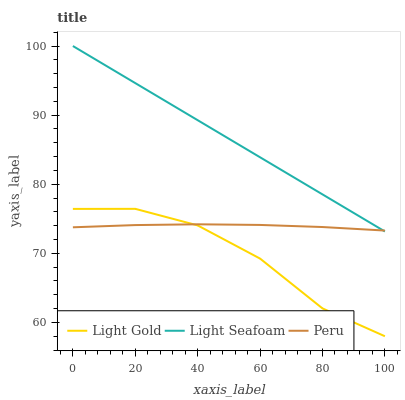Does Light Gold have the minimum area under the curve?
Answer yes or no. Yes. Does Light Seafoam have the maximum area under the curve?
Answer yes or no. Yes. Does Peru have the minimum area under the curve?
Answer yes or no. No. Does Peru have the maximum area under the curve?
Answer yes or no. No. Is Light Seafoam the smoothest?
Answer yes or no. Yes. Is Light Gold the roughest?
Answer yes or no. Yes. Is Peru the smoothest?
Answer yes or no. No. Is Peru the roughest?
Answer yes or no. No. Does Light Gold have the lowest value?
Answer yes or no. Yes. Does Peru have the lowest value?
Answer yes or no. No. Does Light Seafoam have the highest value?
Answer yes or no. Yes. Does Light Gold have the highest value?
Answer yes or no. No. Is Light Gold less than Light Seafoam?
Answer yes or no. Yes. Is Light Seafoam greater than Light Gold?
Answer yes or no. Yes. Does Peru intersect Light Gold?
Answer yes or no. Yes. Is Peru less than Light Gold?
Answer yes or no. No. Is Peru greater than Light Gold?
Answer yes or no. No. Does Light Gold intersect Light Seafoam?
Answer yes or no. No. 